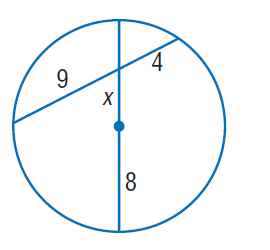Answer the mathemtical geometry problem and directly provide the correct option letter.
Question: Find x. Round to the nearest tenth, if necessary.
Choices: A: 2.7 B: 3 C: 4 D: 5.3 D 